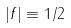Convert formula to latex. <formula><loc_0><loc_0><loc_500><loc_500>| f | \equiv 1 / 2</formula> 